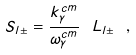Convert formula to latex. <formula><loc_0><loc_0><loc_500><loc_500>S _ { l \pm } = \frac { k _ { \gamma } ^ { c m } } { \omega _ { \gamma } ^ { c m } } \ L _ { l \pm } \ , \</formula> 